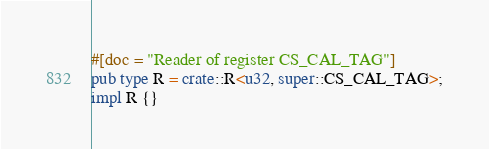<code> <loc_0><loc_0><loc_500><loc_500><_Rust_>#[doc = "Reader of register CS_CAL_TAG"]
pub type R = crate::R<u32, super::CS_CAL_TAG>;
impl R {}
</code> 